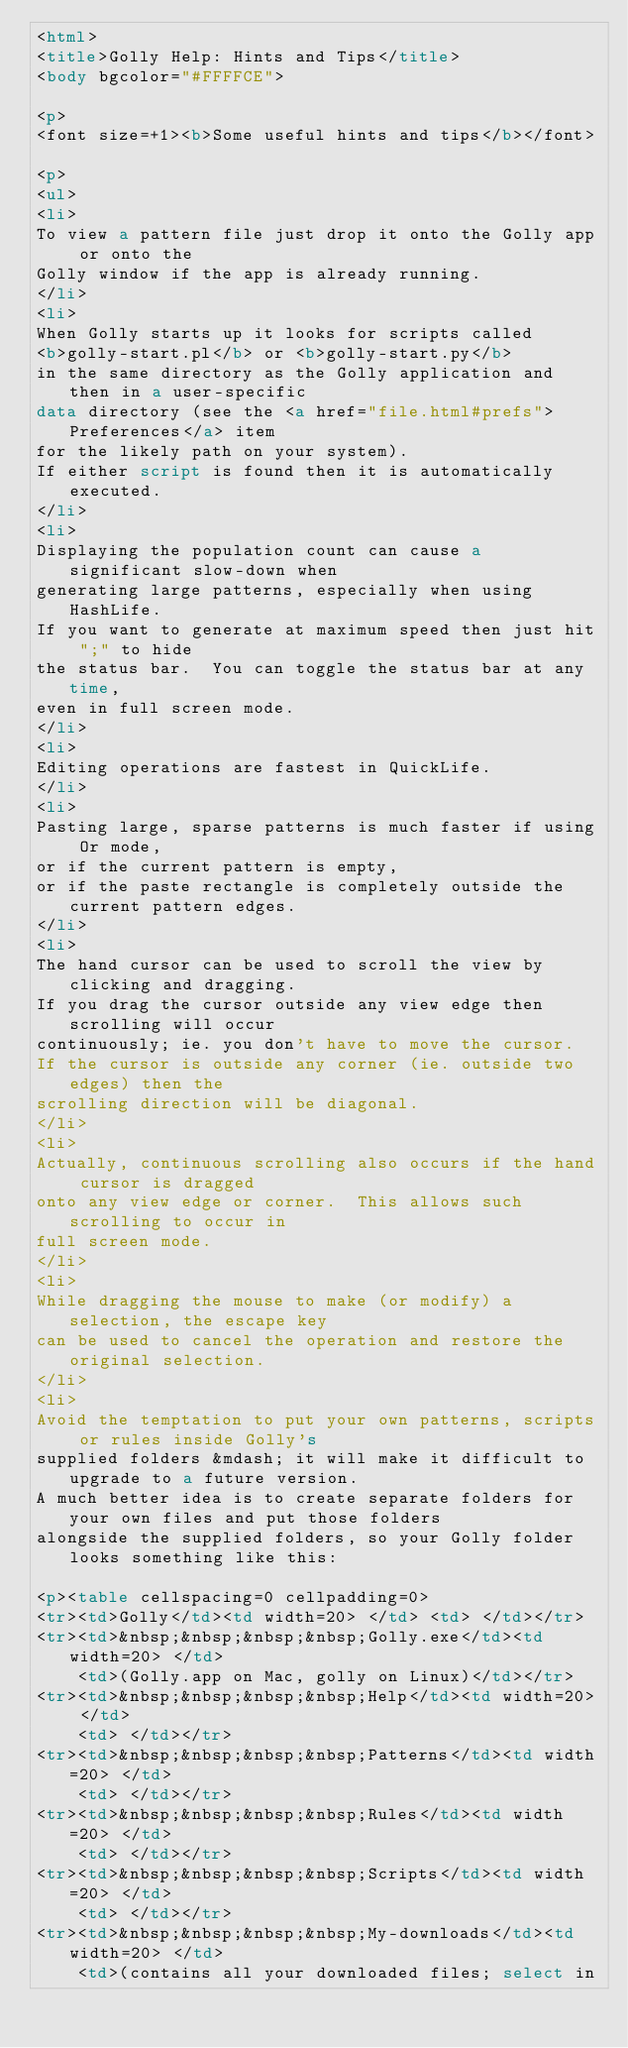<code> <loc_0><loc_0><loc_500><loc_500><_HTML_><html>
<title>Golly Help: Hints and Tips</title>
<body bgcolor="#FFFFCE">

<p>
<font size=+1><b>Some useful hints and tips</b></font>

<p>
<ul>
<li>
To view a pattern file just drop it onto the Golly app or onto the
Golly window if the app is already running.
</li>
<li>
When Golly starts up it looks for scripts called
<b>golly-start.pl</b> or <b>golly-start.py</b>
in the same directory as the Golly application and then in a user-specific
data directory (see the <a href="file.html#prefs">Preferences</a> item
for the likely path on your system).
If either script is found then it is automatically executed.
</li>
<li>
Displaying the population count can cause a significant slow-down when
generating large patterns, especially when using HashLife.
If you want to generate at maximum speed then just hit ";" to hide
the status bar.  You can toggle the status bar at any time,
even in full screen mode.
</li>
<li>
Editing operations are fastest in QuickLife.
</li>
<li>
Pasting large, sparse patterns is much faster if using Or mode,
or if the current pattern is empty,
or if the paste rectangle is completely outside the current pattern edges.
</li>
<li>
The hand cursor can be used to scroll the view by clicking and dragging.
If you drag the cursor outside any view edge then scrolling will occur
continuously; ie. you don't have to move the cursor.
If the cursor is outside any corner (ie. outside two edges) then the
scrolling direction will be diagonal.
</li>
<li>
Actually, continuous scrolling also occurs if the hand cursor is dragged
onto any view edge or corner.  This allows such scrolling to occur in
full screen mode.
</li>
<li>
While dragging the mouse to make (or modify) a selection, the escape key
can be used to cancel the operation and restore the original selection.
</li>
<li>
Avoid the temptation to put your own patterns, scripts or rules inside Golly's
supplied folders &mdash; it will make it difficult to upgrade to a future version.
A much better idea is to create separate folders for your own files and put those folders
alongside the supplied folders, so your Golly folder looks something like this:

<p><table cellspacing=0 cellpadding=0>
<tr><td>Golly</td><td width=20> </td> <td> </td></tr>
<tr><td>&nbsp;&nbsp;&nbsp;&nbsp;Golly.exe</td><td width=20> </td>
    <td>(Golly.app on Mac, golly on Linux)</td></tr>
<tr><td>&nbsp;&nbsp;&nbsp;&nbsp;Help</td><td width=20> </td>
    <td> </td></tr>
<tr><td>&nbsp;&nbsp;&nbsp;&nbsp;Patterns</td><td width=20> </td>
    <td> </td></tr>
<tr><td>&nbsp;&nbsp;&nbsp;&nbsp;Rules</td><td width=20> </td>
    <td> </td></tr>
<tr><td>&nbsp;&nbsp;&nbsp;&nbsp;Scripts</td><td width=20> </td>
    <td> </td></tr>
<tr><td>&nbsp;&nbsp;&nbsp;&nbsp;My-downloads</td><td width=20> </td>
    <td>(contains all your downloaded files; select in</code> 